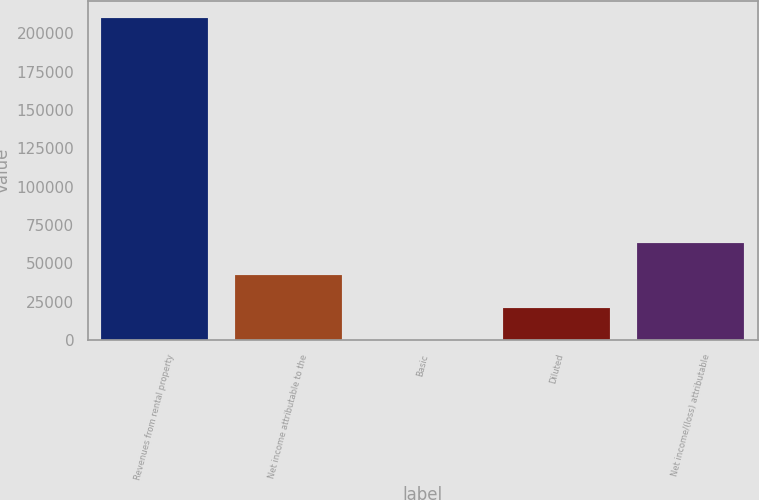<chart> <loc_0><loc_0><loc_500><loc_500><bar_chart><fcel>Revenues from rental property<fcel>Net income attributable to the<fcel>Basic<fcel>Diluted<fcel>Net income/(loss) attributable<nl><fcel>210227<fcel>42045.4<fcel>0.04<fcel>21022.7<fcel>63068.1<nl></chart> 